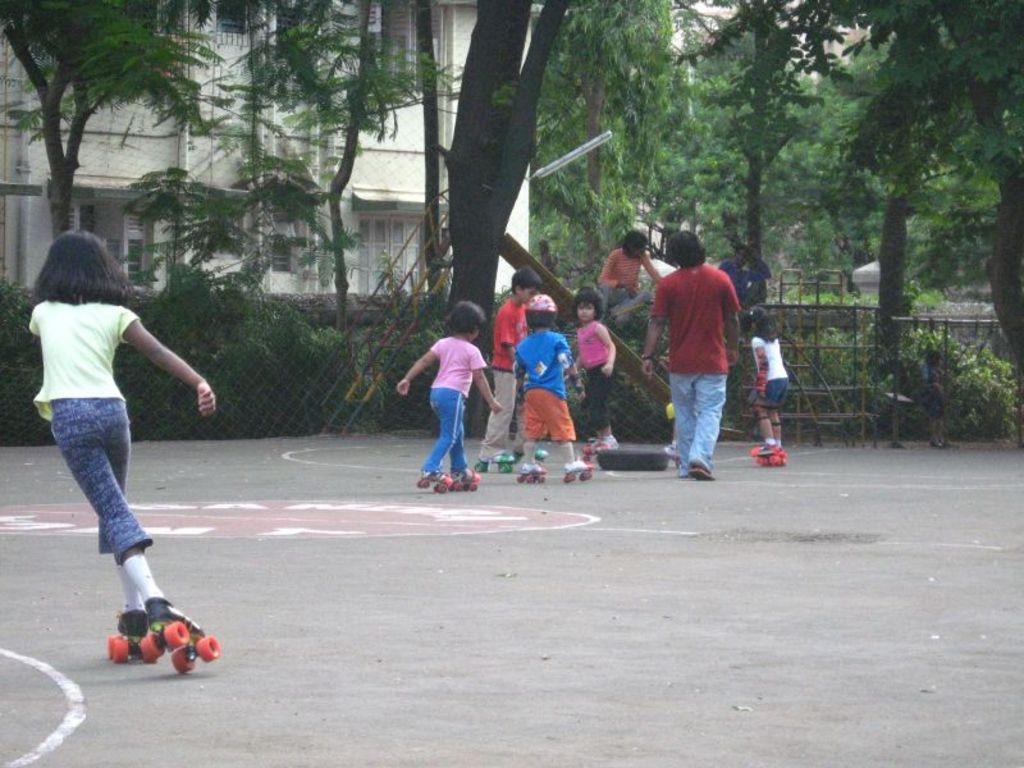Who is present in the image? There are children in the image. What are the children doing in the image? The children are skating on the ground. What can be seen in the middle of the image? There are trees in the middle of the image. What is visible in the background of the image? There is a house in the background of the image. What type of game is being played by the children near the hydrant in the image? There is no hydrant present in the image, and the children are skating, not playing a game. 